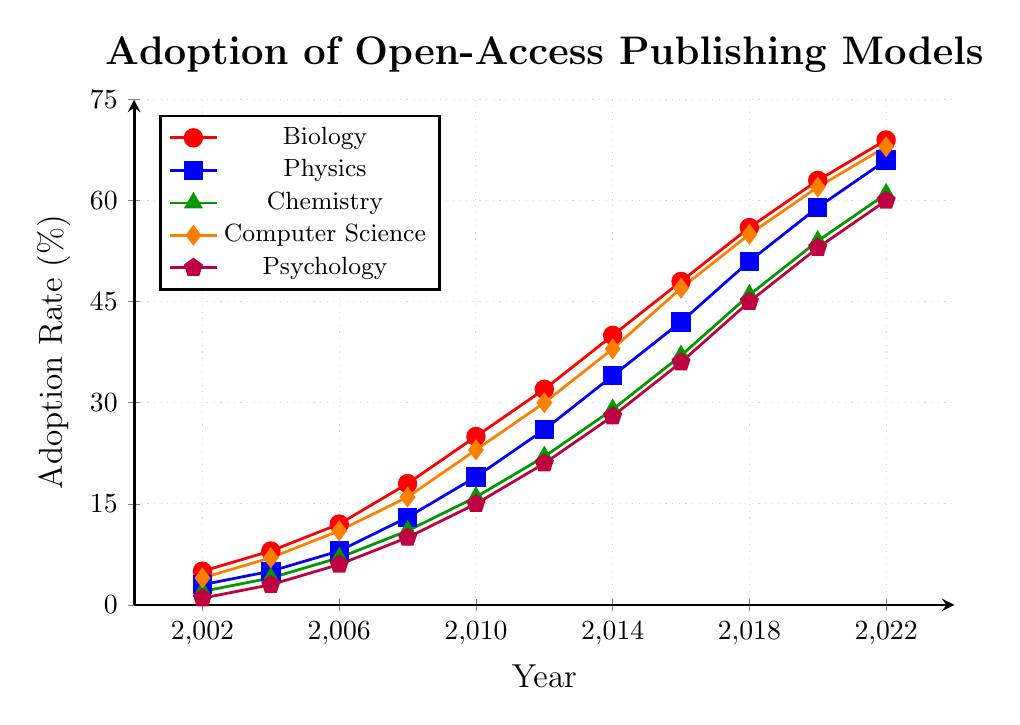what is the adoption rate of Chemistry in 2014? Refer to the Chemistry data in the provided figure. In 2014, the adoption rate for Chemistry is shown at the coordinate (2014,29).
Answer: 29% Which academic field had the highest adoption rate in 2018? Refer to the adoption rates for all fields in 2018. Biology had 56%, Physics had 51%, Chemistry had 46%, Computer Science had 55%, and Psychology had 45%. Biology had the highest value.
Answer: Biology How much did the adoption rate for Computer Science increase from 2002 to 2022? Look at the adoption rates for Computer Science in both years. In 2002 it was 4% and in 2022 it was 68%. The increase is 68 - 4 = 64%.
Answer: 64% Between 2012 and 2016, which field experienced the greatest increase in adoption rate? Look at the differences in adoption rates between 2012 and 2016 for each field: Biology (48-32=16), Physics (42-26=16), Chemistry (37-22=15), Computer Science (47-30=17), and Psychology (36-21=15). Computer Science had the greatest increase.
Answer: Computer Science Which three fields had adoption rates greater than 60% in 2022? Refer to the adoption rates for 2022. Biology (69%), Physics (66%), and Chemistry (61%) all had adoption rates greater than 60%.
Answer: Biology, Physics, Chemistry When did Physics first see its adoption rate exceed 50%? Review the Physics adoption rates over the years. Physics first exceeds 50% in 2018 when the adoption rate was 51%.
Answer: 2018 Compare the adoption rates of Biology and Psychology in 2010. How many times greater was Biology's adoption rate? Biology had an adoption rate of 25% and Psychology had 15%. The ratio is 25 / 15 = 1.67, so Biology's adoption rate was approximately 1.67 times greater.
Answer: 1.67 times In which year did Chemistry surpass a 30% adoption rate? Refer to the Chemistry data. Chemistry surpassed a 30% adoption rate between 2014 and 2016, specifically in 2016 with 37%.
Answer: 2016 What's the difference between the adoption rates of Physics and Chemistry in 2020? Physics had an adoption rate of 59% and Chemistry had 54%. The difference is 59 - 54 = 5%.
Answer: 5% Which field had the slowest initial adoption rate increase between 2002 and 2004? Look at the adoption rates from 2002 to 2004. Biology increased by 3%, Physics by 2%, Chemistry by 2%, Computer Science by 3%, and Psychology by 2%. Chemistry, Physics, and Psychology had the slowest increase of 2%.
Answer: Chemistry, Physics, Psychology 